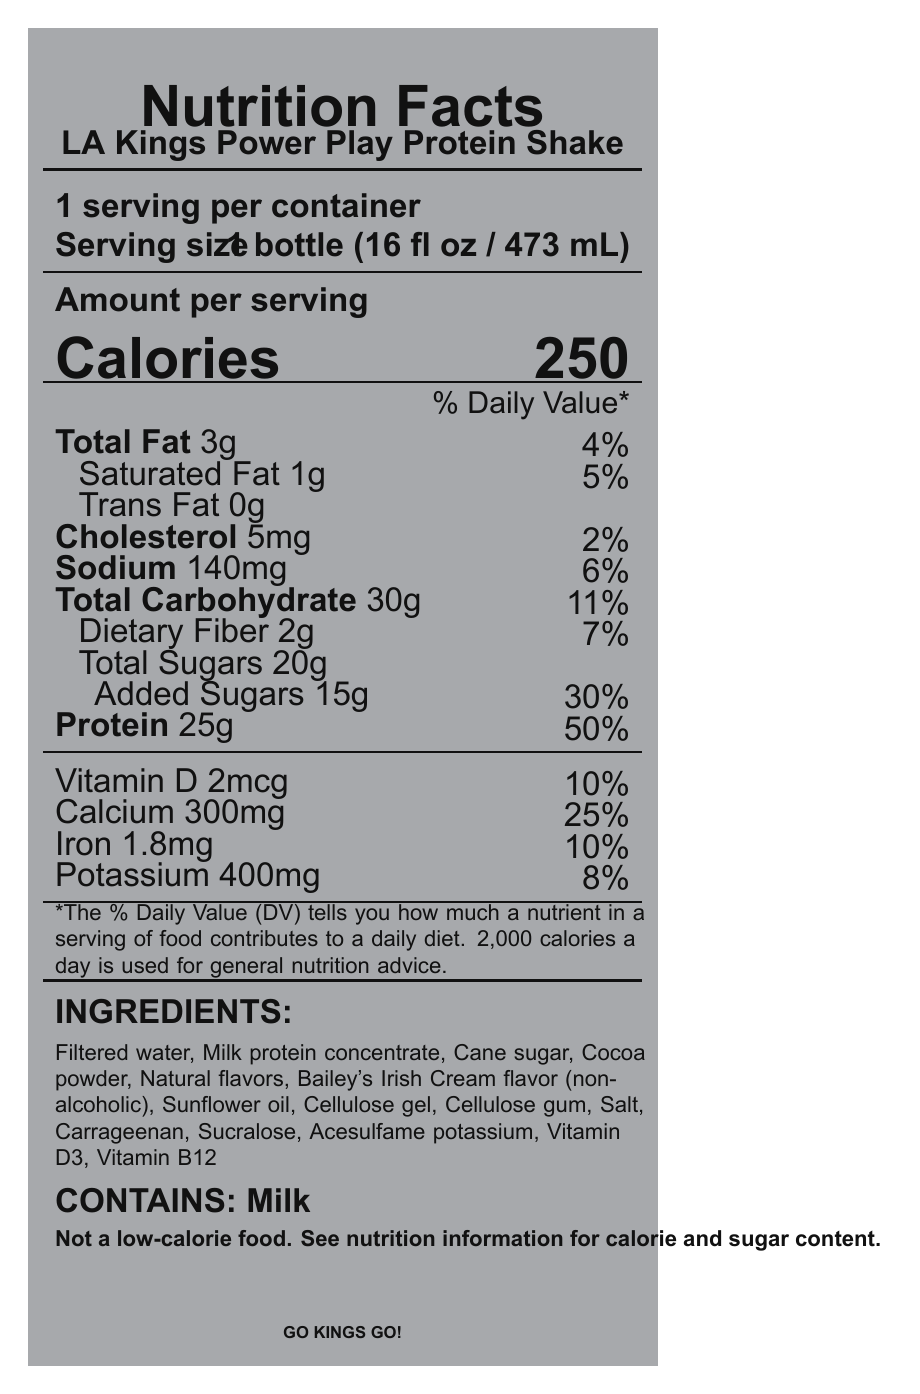what is the serving size for the LA Kings Power Play Protein Shake? The serving size is clearly stated as "1 bottle (16 fl oz / 473 mL)" under the Serving Size section.
Answer: 1 bottle (16 fl oz / 473 mL) how many calories are in one serving? The document states "Calories 250" in the Amount per serving section.
Answer: 250 how much protein does one serving contain? The Protein content is listed as "25g" in the document.
Answer: 25g what percentage of the daily value is the added sugars content? The Added Sugars daily value is listed as "30%" next to its amount.
Answer: 30% list the first three ingredients in the LA Kings Power Play Protein Shake. The first three ingredients are listed in the Ingredients section as "Filtered water, Milk protein concentrate, Cane sugar".
Answer: Filtered water, Milk protein concentrate, Cane sugar what allergens are present in the shake? The allergens section states "Contains milk".
Answer: Milk is this shake considered a low-calorie food? The disclaimer clearly states "Not a low-calorie food."
Answer: No how much dietary fiber does one serving provide? The amount of dietary fiber is listed as "Dietary Fiber 2g" in the document.
Answer: 2g what is the daily value percentage for calcium in one serving? A. 8% B. 10% C. 25% D. 50% The daily value for Calcium is listed as "25%" next to its amount.
Answer: C what is the total carbohydrate content per serving? A. 11g B. 2g C. 30g D. 20g The total carbohydrate content is listed as "30g".
Answer: C how many grams of saturated fat are in one serving? A. 1g B. 2g C. 3g D. 4g The saturated fat content is listed as "Saturated Fat 1g".
Answer: A does the protein shake contain vitamin D? The document lists "Vitamin D 2mcg" in the nutritional information.
Answer: Yes describe the main idea of the document. The document provides comprehensive nutritional information, ingredients, and a product description highlighting its connection to the LA Kings team.
Answer: The nutrition facts label for the LA Kings Power Play Protein Shake provides detailed information about the nutrient content, ingredients, allergens, and suggested usage of the shake, which is themed around the LA Kings hockey team and designed to support energy and nutrition for fans. who is the LA Kings team captain? The team facts section states "captain: Anze Kopitar".
Answer: Anze Kopitar what year was the LA Kings team founded? The team facts section states "founded: 1967".
Answer: 1967 how many Stanley Cups has the LA Kings team won? The team facts section states "stanley cups: 2".
Answer: 2 what is the sodium content per serving? The sodium content is listed as "Sodium 140mg".
Answer: 140mg what natural flavor is included in the ingredients? The ingredients list includes "Bailey's Irish Cream flavor (non-alcoholic)" as one of the natural flavors.
Answer: Bailey's Irish Cream flavor (non-alcoholic) how much iron is in each serving? The Iron content is listed as "Iron 1.8mg".
Answer: 1.8mg how many home games does the LA Kings play each season? The document does not provide any information about the number of home games the LA Kings play each season.
Answer: Cannot be determined 